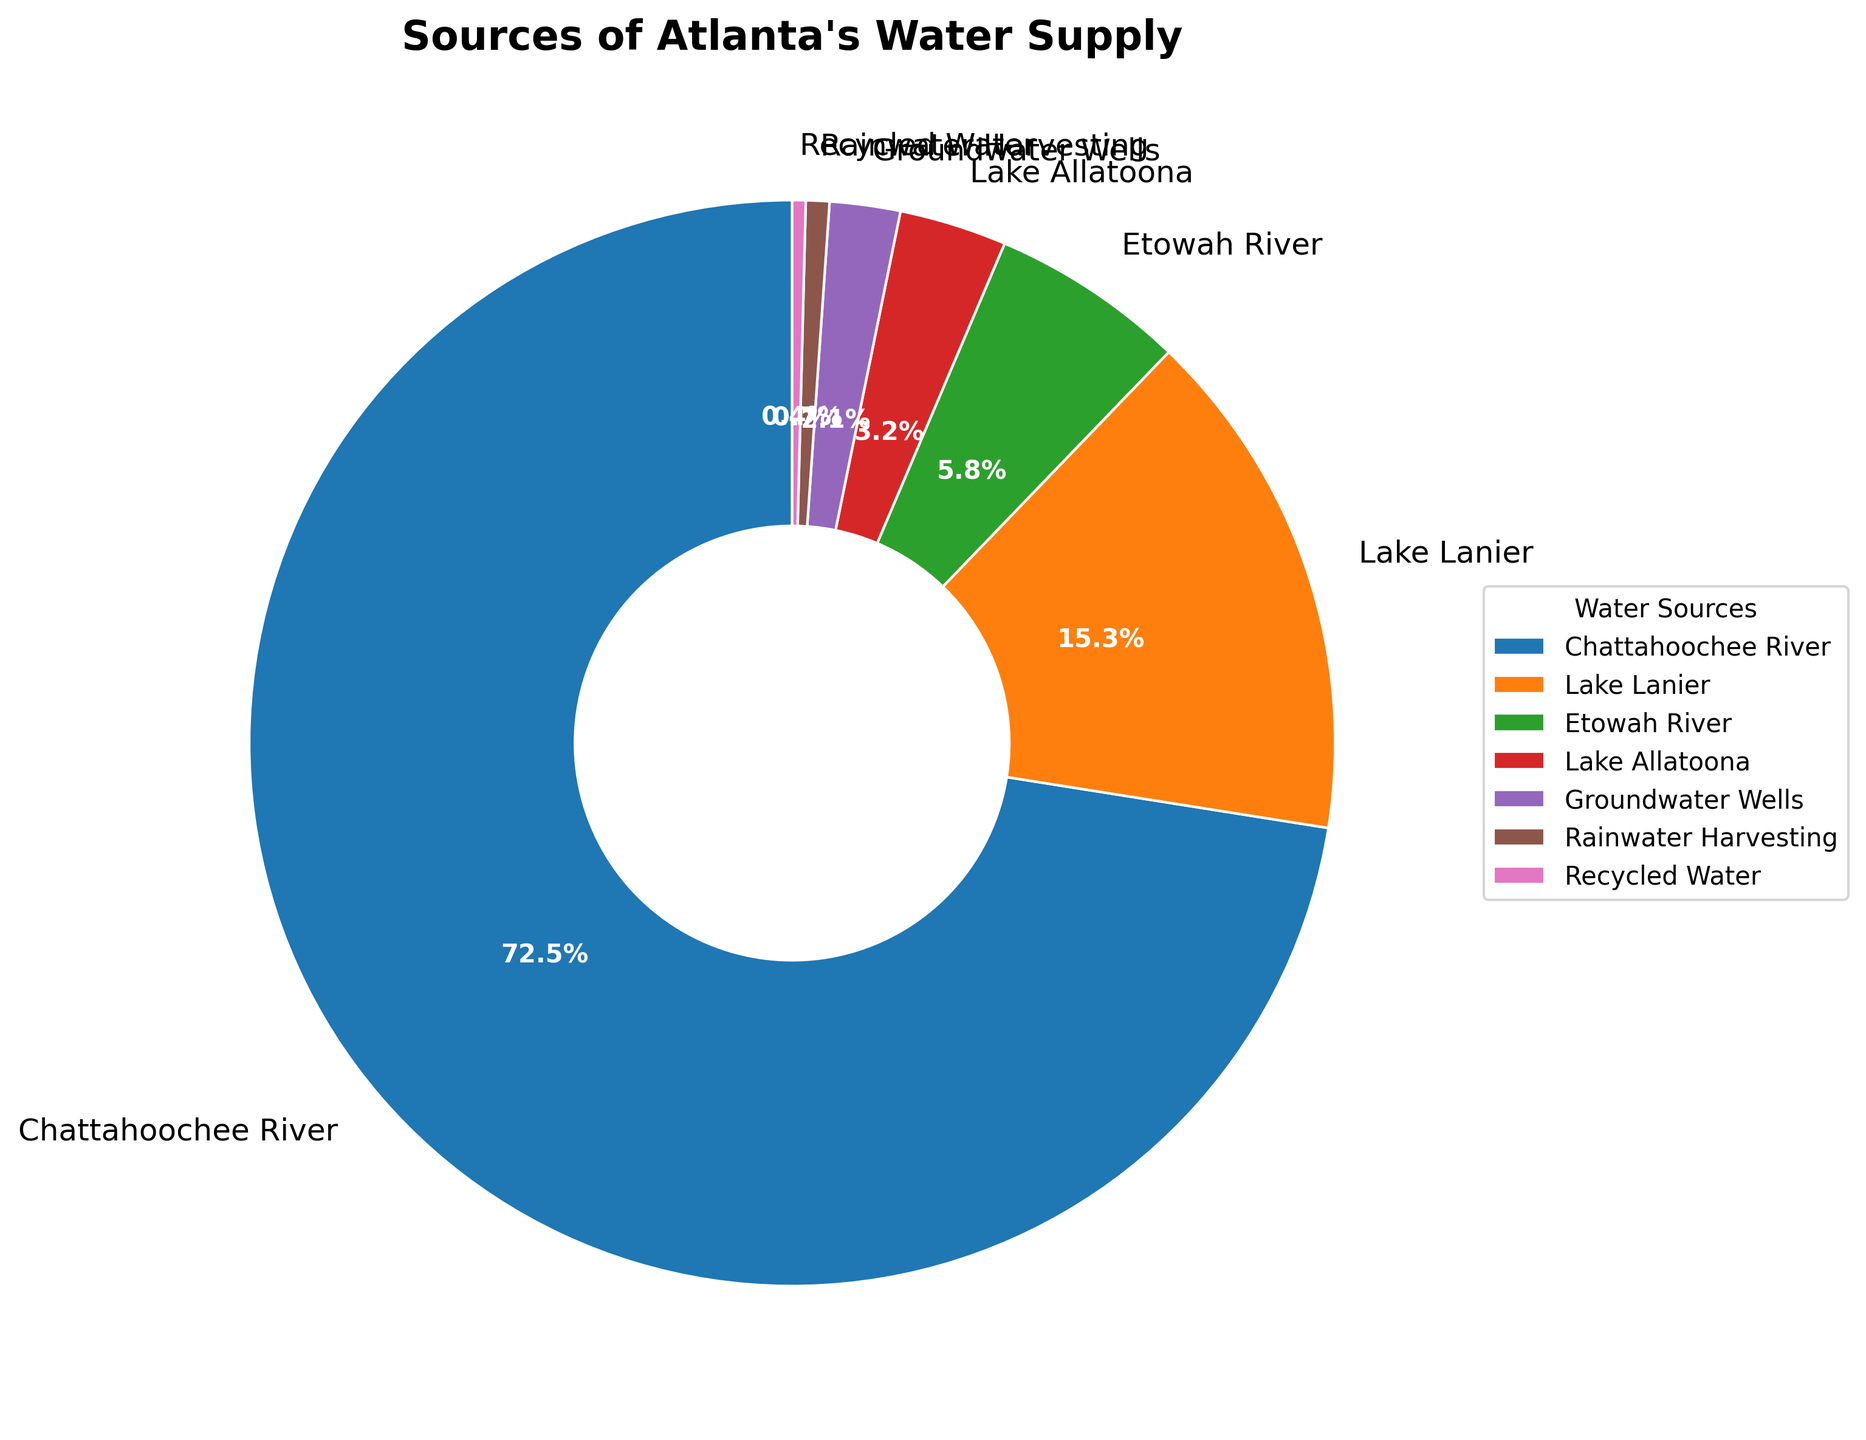What percentage of Atlanta's water supply comes from the Chattahoochee River and Lake Lanier combined? To find the combined percentage, add the percentages of water supplied by the Chattahoochee River and Lake Lanier: 72.5% + 15.3% = 87.8%.
Answer: 87.8% Which source provides a smaller percentage of water supply, Recycled Water or Rainwater Harvesting? Compare the percentages of Recycled Water (0.4%) and Rainwater Harvesting (0.7%). Recycled Water provides a smaller percentage.
Answer: Recycled Water What is the difference in water supply percentages between the Chattahoochee River and the Etowah River? Subtract the Etowah River percentage from the Chattahoochee River percentage: 72.5% - 5.8% = 66.7%.
Answer: 66.7% Which source is depicted in orange on the pie chart? The pie chart uses distinct colors for each source. The source in orange is labeled "Lake Lanier."
Answer: Lake Lanier How many sources provide less than 5% of Atlanta's water supply? Identify all sources with percentages below 5%: Etowah River (5.8%), Lake Allatoona (3.2%), Groundwater Wells (2.1%), Rainwater Harvesting (0.7%), and Recycled Water (0.4%). Count these sources. There are 5 such sources.
Answer: 5 What percentage does Groundwater Wells contribute to the water supply? Refer to the labeled sections of the pie chart. Groundwater Wells contribute 2.1% to the water supply.
Answer: 2.1% Which source provides more water, Lake Allatoona or the Etowah River? Compare the percentages for Lake Allatoona (3.2%) and the Etowah River (5.8%). The Etowah River provides more water.
Answer: Etowah River What is the total percentage of water supply provided by sources other than the Chattahoochee River? Add percentages of all sources except the Chattahoochee River: 15.3% (Lake Lanier) + 5.8% (Etowah River) + 3.2% (Lake Allatoona) + 2.1% (Groundwater Wells) + 0.7% (Rainwater Harvesting) + 0.4% (Recycled Water) = 27.5%.
Answer: 27.5% Is the section representing the Etowah River larger than the section representing Lake Allatoona in the pie chart? Compare the visual size of the sectors: the Etowah River (5.8%) versus Lake Allatoona (3.2%). The Etowah River section is larger.
Answer: Yes Which source is represented by the smallest section in the pie chart? Identify the source with the smallest percentage: Recycled Water with 0.4%.
Answer: Recycled Water 